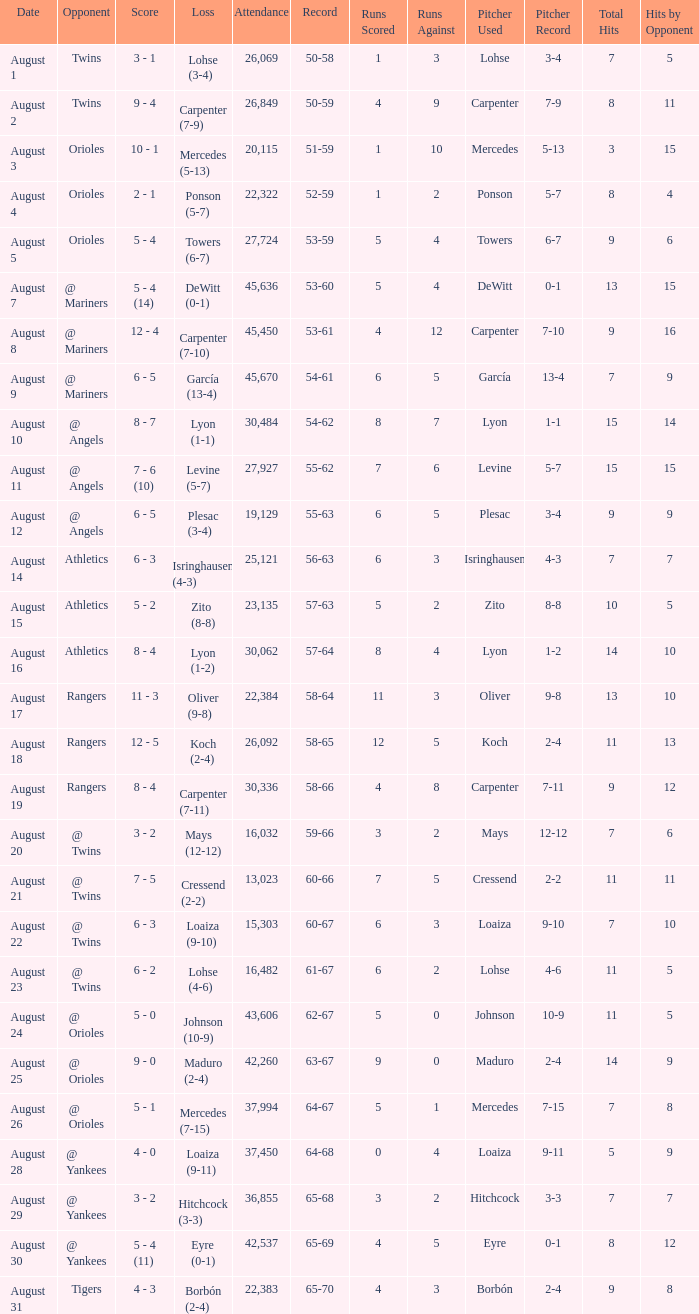What was the score of the game when their record was 62-67 5 - 0. 